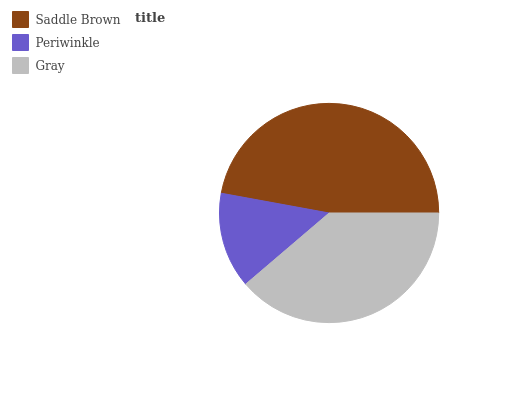Is Periwinkle the minimum?
Answer yes or no. Yes. Is Saddle Brown the maximum?
Answer yes or no. Yes. Is Gray the minimum?
Answer yes or no. No. Is Gray the maximum?
Answer yes or no. No. Is Gray greater than Periwinkle?
Answer yes or no. Yes. Is Periwinkle less than Gray?
Answer yes or no. Yes. Is Periwinkle greater than Gray?
Answer yes or no. No. Is Gray less than Periwinkle?
Answer yes or no. No. Is Gray the high median?
Answer yes or no. Yes. Is Gray the low median?
Answer yes or no. Yes. Is Periwinkle the high median?
Answer yes or no. No. Is Periwinkle the low median?
Answer yes or no. No. 